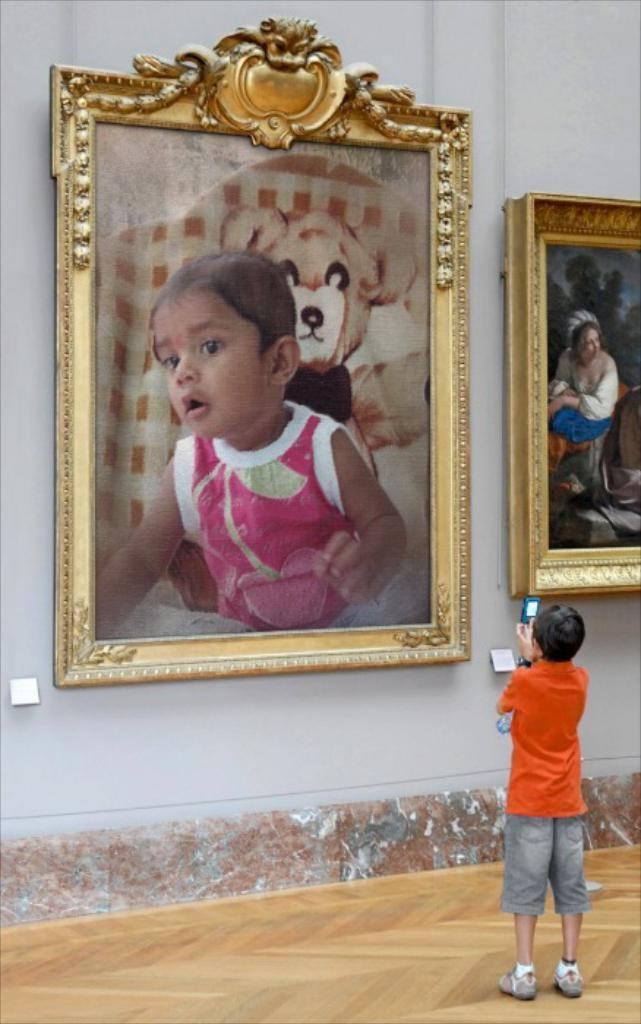What is the main subject of the image? The main subject of the image is a kid. What is the kid wearing? The kid is wearing an orange T-shirt. What is the kid holding in the image? The kid is holding a mobile. What type of surface is visible in the image? There is a floor visible in the image. What can be seen on the wall in the image? There are two frames on the wall. What type of meal is being prepared in the image? There is no meal preparation visible in the image; it features a kid holding a mobile. Can you tell me what kind of stamp is on the wall in the image? There is no stamp present on the wall in the image; it features two frames. 